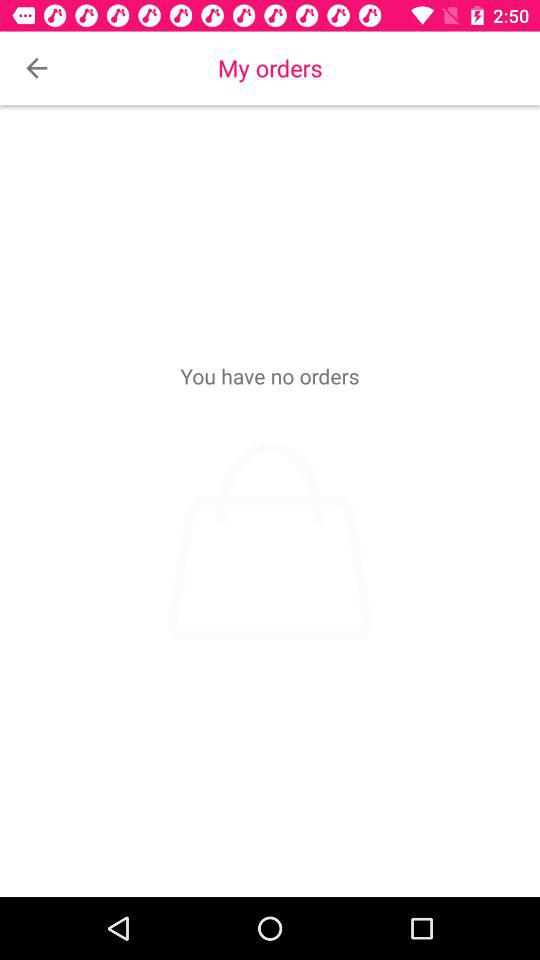How many orders do I have?
Answer the question using a single word or phrase. 0 